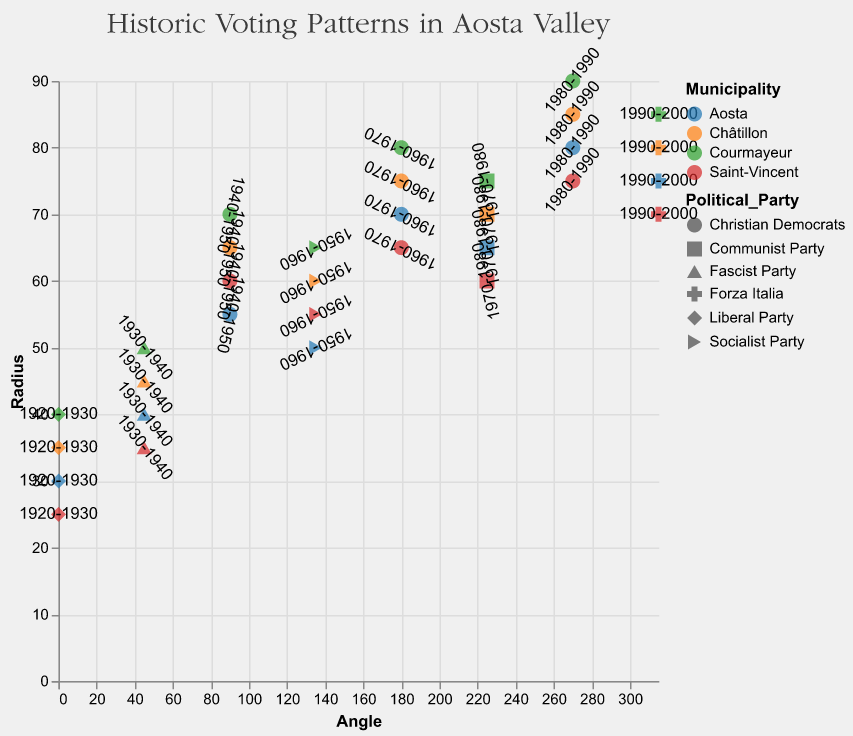What is the title of the chart? The title of the chart is displayed at the top of the figure.
Answer: Historic Voting Patterns in Aosta Valley How many municipalities are represented in the chart? By counting the unique color categories representing different municipalities in the legend or chart, we can determine there are four municipalities.
Answer: 4 Which municipality has the largest radius value and during which decade? By observing the radial distance, the largest radius value is 90 for Courmayeur during the decade 1980-1990.
Answer: Courmayeur, 1980-1990 Which political party had the most influence in the 1970-1980 decade in Aosta Valley? Points at the 225-degree mark across different colors indicate the political party's influence. The Communist Party had influence in all municipalities during this decade.
Answer: Communist Party Compare the radius of Forza Italia in Aosta and Courmayeur for the decade 1990-2000. Which one is larger? Observing the data points at the 315-degree mark, Aosta has a radius of 75, and Courmayeur has a radius of 85. Therefore, Courmayeur's radius is larger.
Answer: Courmayeur What was the dominant political party in Châtillon during the 1960-1970 decade? The data point at the 180-degree angle corresponds to the Christian Democrats for Châtillon in the decade 1960-1970.
Answer: Christian Democrats What trend can be observed regarding the radius values of Christian Democrats over the decades in Saint-Vincent? The radius values for Christian Democrats in Saint-Vincent increase over time (60, 65, 75). This indicates growing influence or popularity over the decades.
Answer: Increasing trend Calculate the average radius for Socialist Party across all municipalities in the 1950-1960 decade. Identifying the Socialist Party's radius values from different municipalities for the 1950-1960 decade: Aosta (50), Saint-Vincent (55), Courmayeur (65), Châtillon (60). Summing these (50 + 55 + 65 + 60 = 230) and dividing by the number of points (4), we get 57.5.
Answer: 57.5 